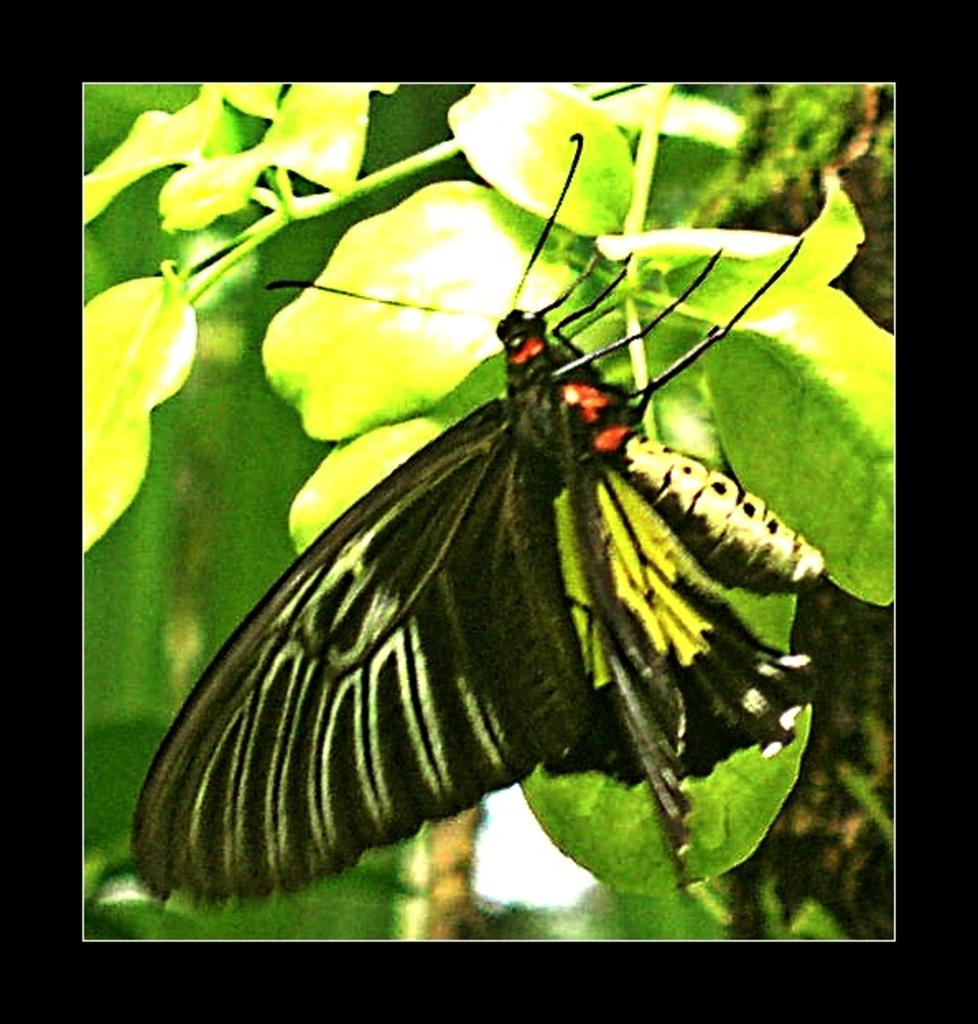What is the main subject of the image? There is a butterfly in the image. Where is the butterfly located? The butterfly is on a leaf. What type of mint is the butterfly using to answer questions in the image? There is no mint or questioning activity present in the image; it features a butterfly on a leaf. 